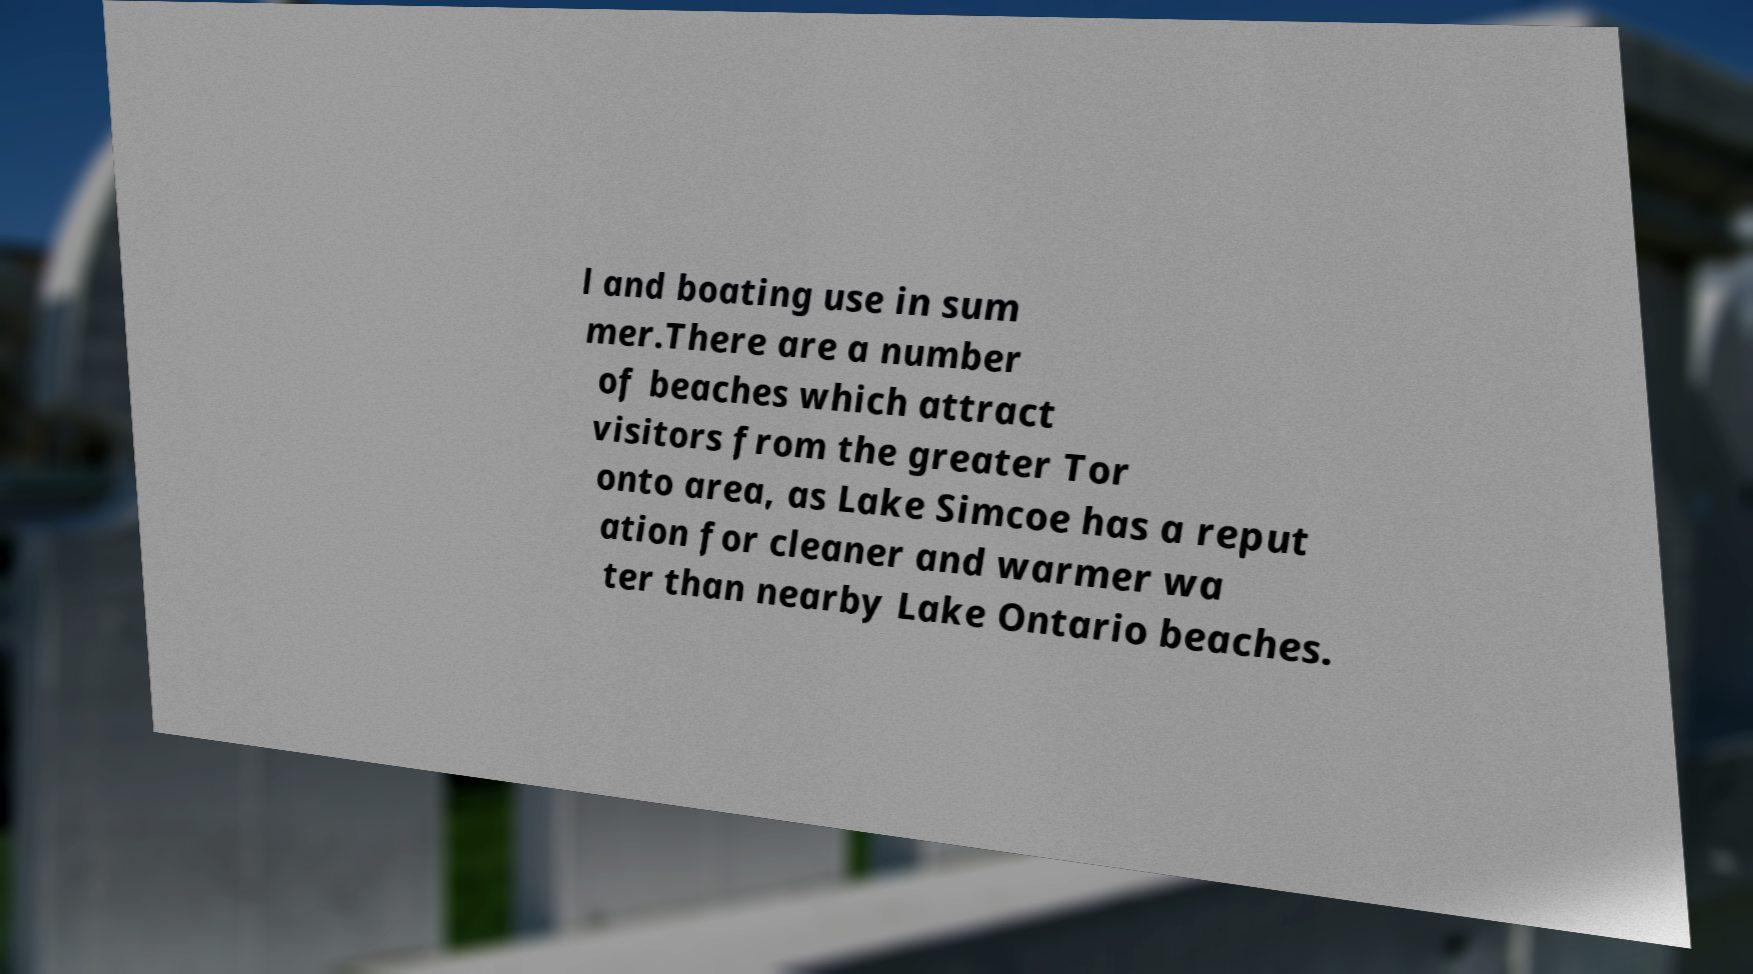Could you assist in decoding the text presented in this image and type it out clearly? l and boating use in sum mer.There are a number of beaches which attract visitors from the greater Tor onto area, as Lake Simcoe has a reput ation for cleaner and warmer wa ter than nearby Lake Ontario beaches. 